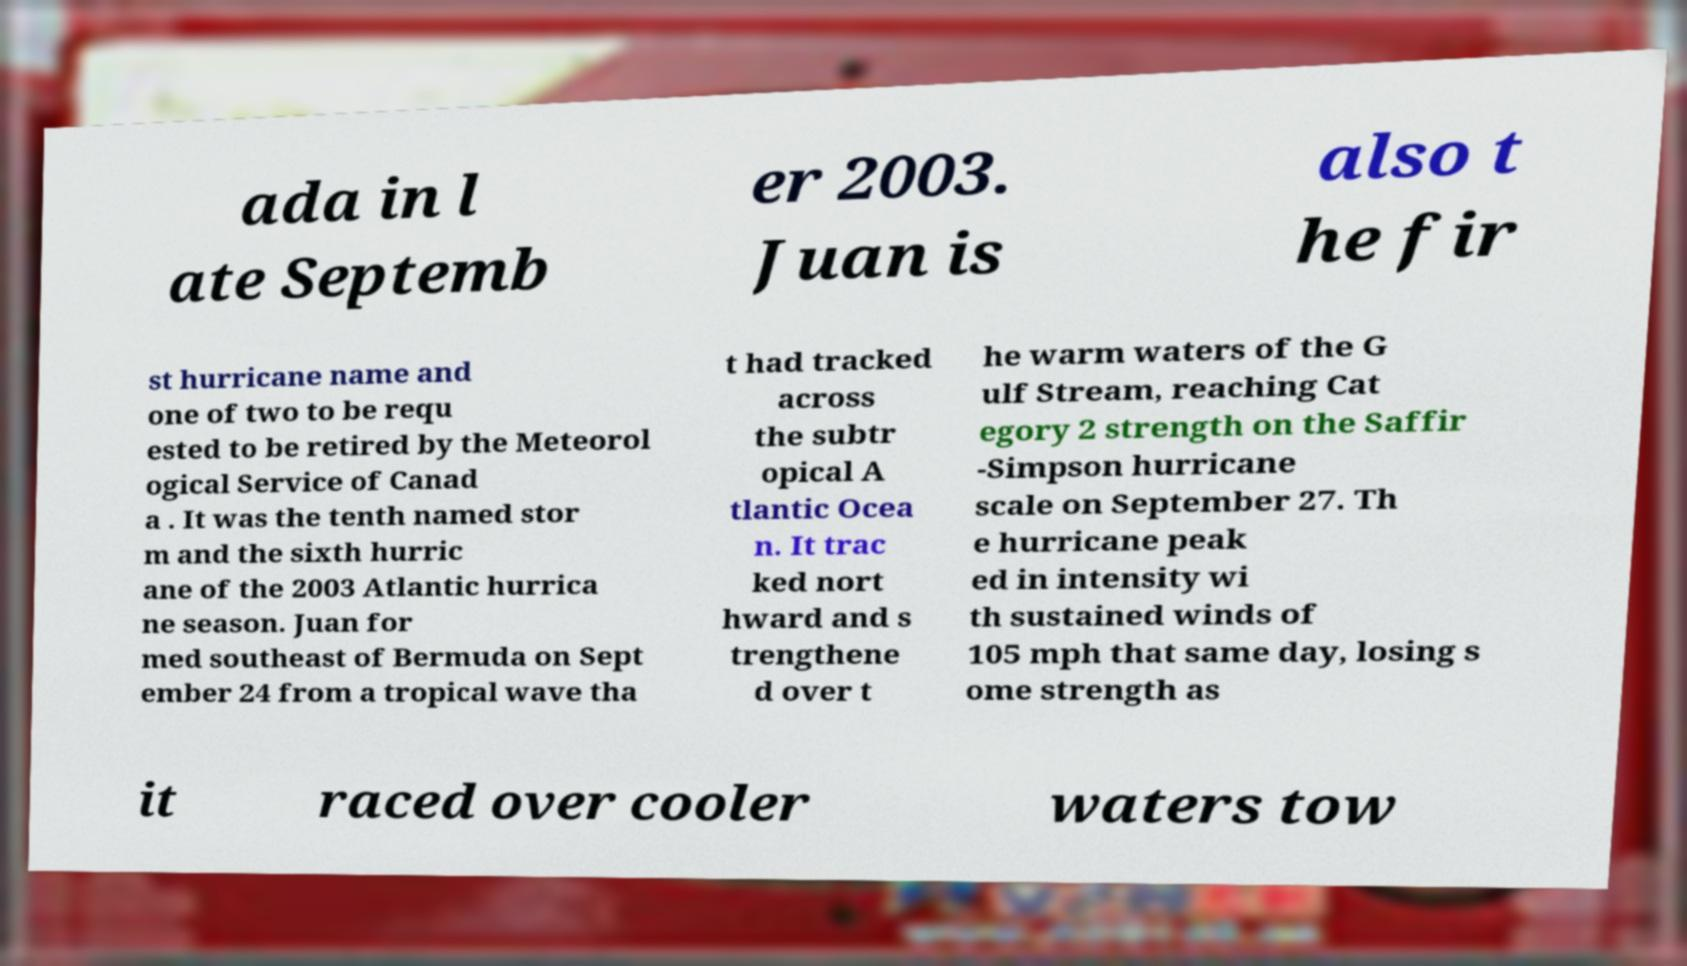Can you read and provide the text displayed in the image?This photo seems to have some interesting text. Can you extract and type it out for me? ada in l ate Septemb er 2003. Juan is also t he fir st hurricane name and one of two to be requ ested to be retired by the Meteorol ogical Service of Canad a . It was the tenth named stor m and the sixth hurric ane of the 2003 Atlantic hurrica ne season. Juan for med southeast of Bermuda on Sept ember 24 from a tropical wave tha t had tracked across the subtr opical A tlantic Ocea n. It trac ked nort hward and s trengthene d over t he warm waters of the G ulf Stream, reaching Cat egory 2 strength on the Saffir -Simpson hurricane scale on September 27. Th e hurricane peak ed in intensity wi th sustained winds of 105 mph that same day, losing s ome strength as it raced over cooler waters tow 